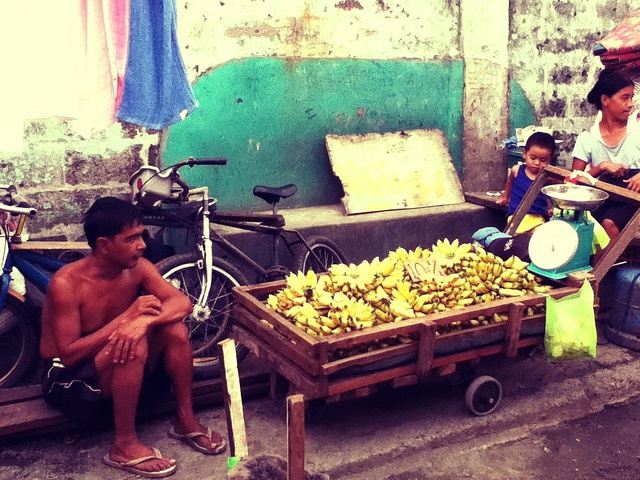Describe the objects in this image and their specific colors. I can see people in lightyellow, purple, black, brown, and salmon tones, bicycle in lightyellow, navy, purple, and gray tones, banana in lightyellow, khaki, tan, and maroon tones, bicycle in lightyellow, navy, purple, and brown tones, and people in lightyellow, navy, salmon, and brown tones in this image. 